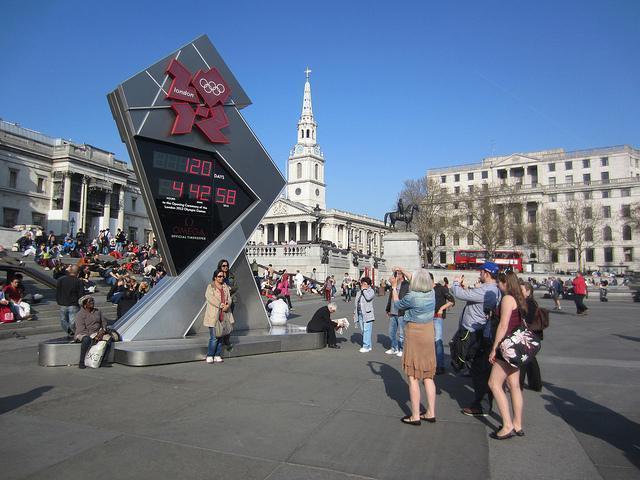What event do the rings signify?
Choose the right answer from the provided options to respond to the question.
Options: Dolphin show, square dance, school play, olympics. Olympics. 